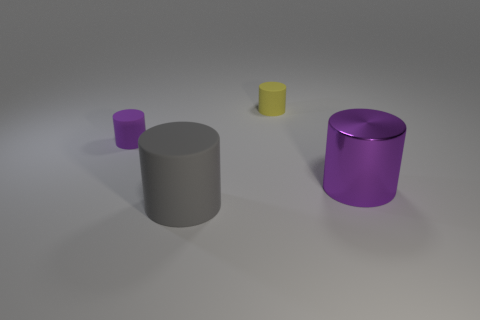Subtract all red cylinders. Subtract all green cubes. How many cylinders are left? 4 Add 3 gray things. How many objects exist? 7 Add 2 tiny objects. How many tiny objects are left? 4 Add 4 big objects. How many big objects exist? 6 Subtract 0 cyan blocks. How many objects are left? 4 Subtract all big brown shiny cylinders. Subtract all big purple metal cylinders. How many objects are left? 3 